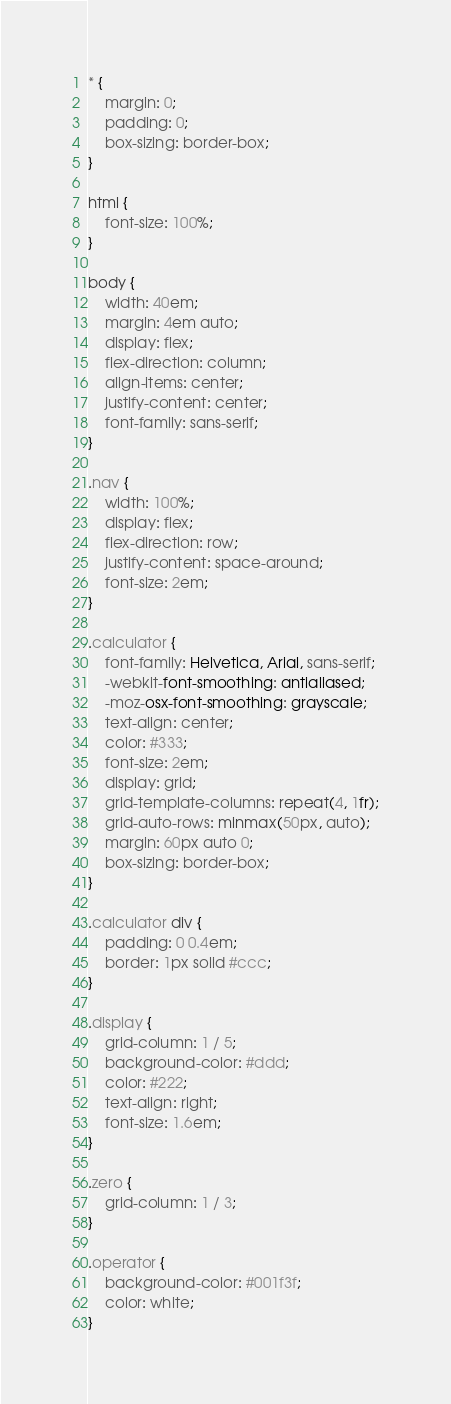Convert code to text. <code><loc_0><loc_0><loc_500><loc_500><_CSS_>* {
    margin: 0;
    padding: 0;
    box-sizing: border-box;
}

html {
    font-size: 100%;
}

body {
    width: 40em;
    margin: 4em auto;
    display: flex;
    flex-direction: column;
    align-items: center;
    justify-content: center;
    font-family: sans-serif;
}

.nav {
    width: 100%;
    display: flex;
    flex-direction: row;
    justify-content: space-around;
    font-size: 2em;
}

.calculator {
    font-family: Helvetica, Arial, sans-serif;
    -webkit-font-smoothing: antialiased;
    -moz-osx-font-smoothing: grayscale;
    text-align: center;
    color: #333;
    font-size: 2em;
    display: grid;
    grid-template-columns: repeat(4, 1fr);
    grid-auto-rows: minmax(50px, auto);
    margin: 60px auto 0;
    box-sizing: border-box;
}

.calculator div {
    padding: 0 0.4em;
    border: 1px solid #ccc;
}

.display {
    grid-column: 1 / 5;
    background-color: #ddd;
    color: #222;
    text-align: right;
    font-size: 1.6em;
}

.zero {
    grid-column: 1 / 3;
}

.operator {
    background-color: #001f3f;
    color: white;
}
</code> 